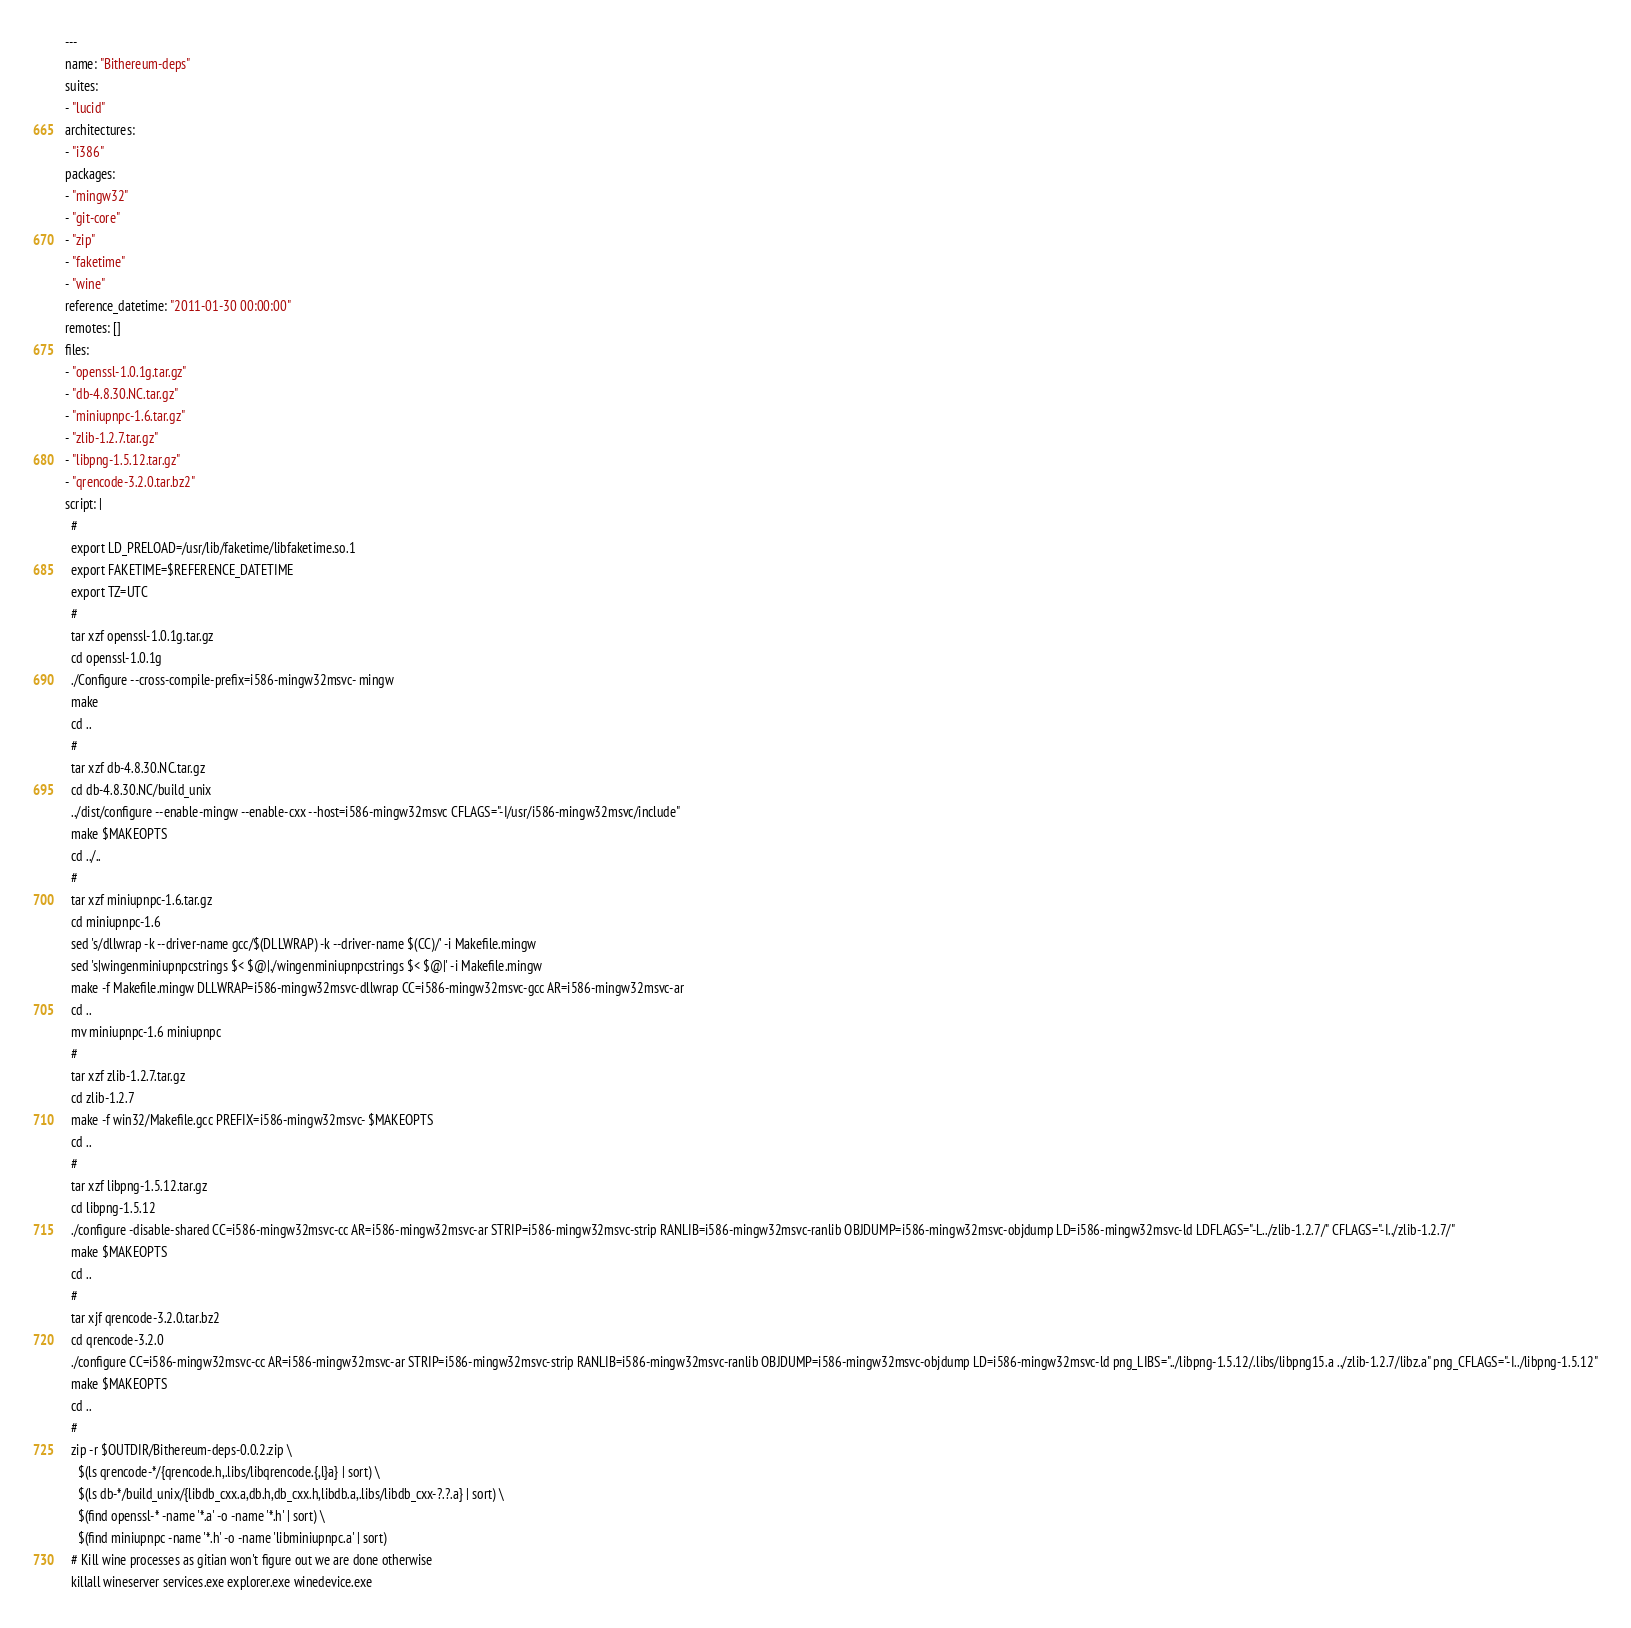<code> <loc_0><loc_0><loc_500><loc_500><_YAML_>---
name: "Bithereum-deps"
suites:
- "lucid"
architectures:
- "i386"
packages: 
- "mingw32"
- "git-core"
- "zip"
- "faketime"
- "wine"
reference_datetime: "2011-01-30 00:00:00"
remotes: []
files:
- "openssl-1.0.1g.tar.gz"
- "db-4.8.30.NC.tar.gz"
- "miniupnpc-1.6.tar.gz"
- "zlib-1.2.7.tar.gz"
- "libpng-1.5.12.tar.gz"
- "qrencode-3.2.0.tar.bz2"
script: |
  #
  export LD_PRELOAD=/usr/lib/faketime/libfaketime.so.1
  export FAKETIME=$REFERENCE_DATETIME
  export TZ=UTC
  #
  tar xzf openssl-1.0.1g.tar.gz
  cd openssl-1.0.1g
  ./Configure --cross-compile-prefix=i586-mingw32msvc- mingw
  make
  cd ..
  #
  tar xzf db-4.8.30.NC.tar.gz
  cd db-4.8.30.NC/build_unix
  ../dist/configure --enable-mingw --enable-cxx --host=i586-mingw32msvc CFLAGS="-I/usr/i586-mingw32msvc/include"
  make $MAKEOPTS
  cd ../..
  #
  tar xzf miniupnpc-1.6.tar.gz
  cd miniupnpc-1.6
  sed 's/dllwrap -k --driver-name gcc/$(DLLWRAP) -k --driver-name $(CC)/' -i Makefile.mingw
  sed 's|wingenminiupnpcstrings $< $@|./wingenminiupnpcstrings $< $@|' -i Makefile.mingw
  make -f Makefile.mingw DLLWRAP=i586-mingw32msvc-dllwrap CC=i586-mingw32msvc-gcc AR=i586-mingw32msvc-ar
  cd ..
  mv miniupnpc-1.6 miniupnpc
  #
  tar xzf zlib-1.2.7.tar.gz
  cd zlib-1.2.7
  make -f win32/Makefile.gcc PREFIX=i586-mingw32msvc- $MAKEOPTS
  cd ..
  #
  tar xzf libpng-1.5.12.tar.gz
  cd libpng-1.5.12
  ./configure -disable-shared CC=i586-mingw32msvc-cc AR=i586-mingw32msvc-ar STRIP=i586-mingw32msvc-strip RANLIB=i586-mingw32msvc-ranlib OBJDUMP=i586-mingw32msvc-objdump LD=i586-mingw32msvc-ld LDFLAGS="-L../zlib-1.2.7/" CFLAGS="-I../zlib-1.2.7/"
  make $MAKEOPTS
  cd ..
  #
  tar xjf qrencode-3.2.0.tar.bz2
  cd qrencode-3.2.0
  ./configure CC=i586-mingw32msvc-cc AR=i586-mingw32msvc-ar STRIP=i586-mingw32msvc-strip RANLIB=i586-mingw32msvc-ranlib OBJDUMP=i586-mingw32msvc-objdump LD=i586-mingw32msvc-ld png_LIBS="../libpng-1.5.12/.libs/libpng15.a ../zlib-1.2.7/libz.a" png_CFLAGS="-I../libpng-1.5.12"
  make $MAKEOPTS
  cd ..
  #
  zip -r $OUTDIR/Bithereum-deps-0.0.2.zip \
    $(ls qrencode-*/{qrencode.h,.libs/libqrencode.{,l}a} | sort) \
    $(ls db-*/build_unix/{libdb_cxx.a,db.h,db_cxx.h,libdb.a,.libs/libdb_cxx-?.?.a} | sort) \
    $(find openssl-* -name '*.a' -o -name '*.h' | sort) \
    $(find miniupnpc -name '*.h' -o -name 'libminiupnpc.a' | sort)
  # Kill wine processes as gitian won't figure out we are done otherwise
  killall wineserver services.exe explorer.exe winedevice.exe
</code> 